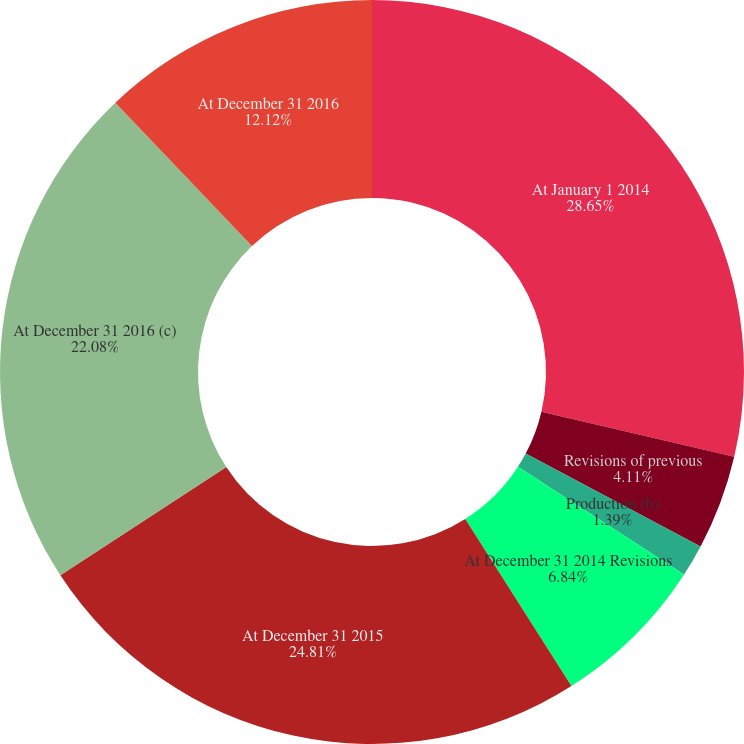<chart> <loc_0><loc_0><loc_500><loc_500><pie_chart><fcel>At January 1 2014<fcel>Revisions of previous<fcel>Production (b)<fcel>At December 31 2014 Revisions<fcel>At December 31 2015<fcel>At December 31 2016 (c)<fcel>At December 31 2016<nl><fcel>28.66%<fcel>4.11%<fcel>1.39%<fcel>6.84%<fcel>24.81%<fcel>22.08%<fcel>12.12%<nl></chart> 